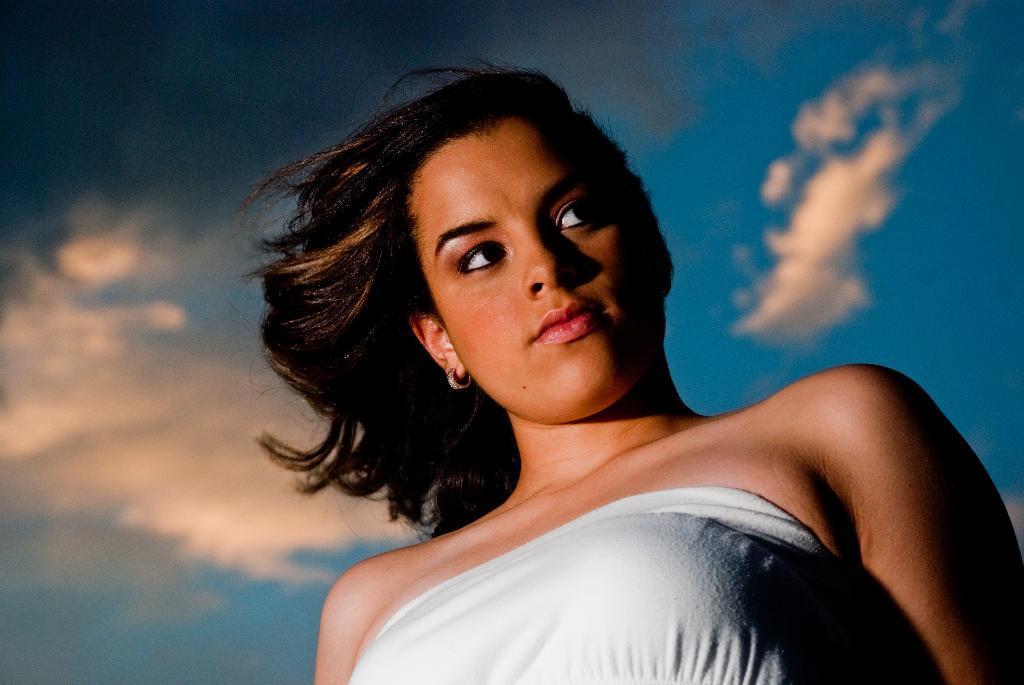Could you give a brief overview of what you see in this image? In this picture I can see a woman and a blue cloudy sky. 